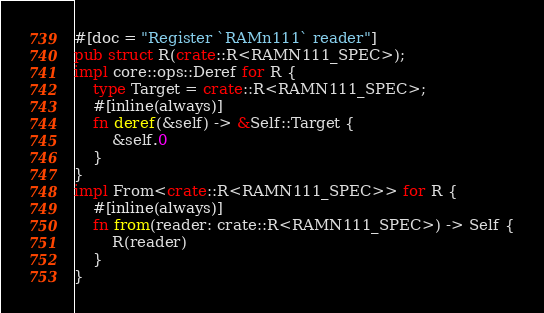<code> <loc_0><loc_0><loc_500><loc_500><_Rust_>#[doc = "Register `RAMn111` reader"]
pub struct R(crate::R<RAMN111_SPEC>);
impl core::ops::Deref for R {
    type Target = crate::R<RAMN111_SPEC>;
    #[inline(always)]
    fn deref(&self) -> &Self::Target {
        &self.0
    }
}
impl From<crate::R<RAMN111_SPEC>> for R {
    #[inline(always)]
    fn from(reader: crate::R<RAMN111_SPEC>) -> Self {
        R(reader)
    }
}</code> 